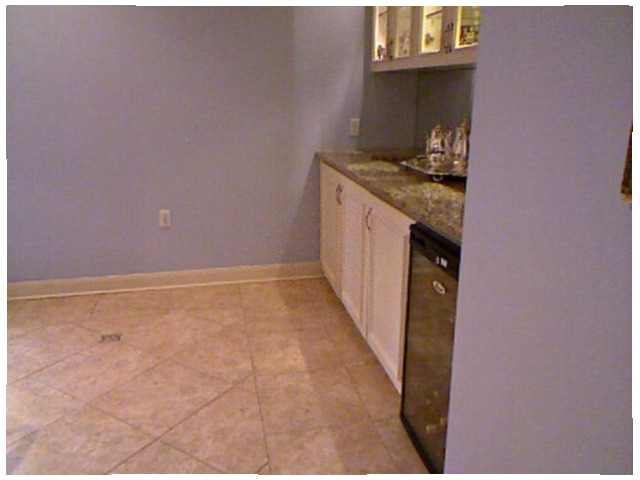<image>
Can you confirm if the tea set is above the floor? Yes. The tea set is positioned above the floor in the vertical space, higher up in the scene. 